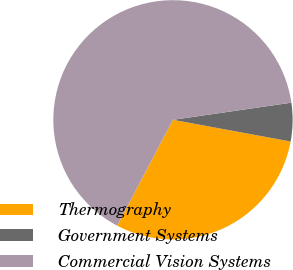<chart> <loc_0><loc_0><loc_500><loc_500><pie_chart><fcel>Thermography<fcel>Government Systems<fcel>Commercial Vision Systems<nl><fcel>29.82%<fcel>5.19%<fcel>64.99%<nl></chart> 